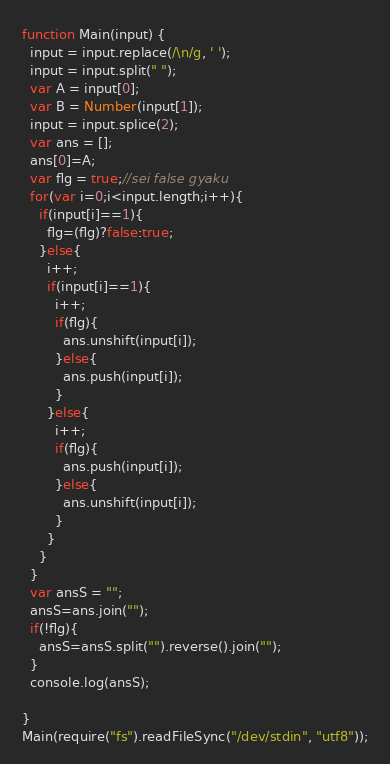<code> <loc_0><loc_0><loc_500><loc_500><_JavaScript_>function Main(input) {
  input = input.replace(/\n/g, ' ');
  input = input.split(" ");
  var A = input[0];
  var B = Number(input[1]);
  input = input.splice(2);
  var ans = [];
  ans[0]=A;
  var flg = true;//sei false gyaku
  for(var i=0;i<input.length;i++){
    if(input[i]==1){
      flg=(flg)?false:true;
    }else{
      i++;
      if(input[i]==1){
        i++;
        if(flg){
          ans.unshift(input[i]);
        }else{
          ans.push(input[i]);
        }
      }else{
        i++;
        if(flg){
          ans.push(input[i]);
        }else{
          ans.unshift(input[i]);
        }
      }
    }
  }
  var ansS = "";
  ansS=ans.join("");
  if(!flg){
    ansS=ansS.split("").reverse().join("");
  }
  console.log(ansS);

}
Main(require("fs").readFileSync("/dev/stdin", "utf8"));</code> 